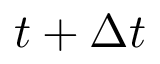Convert formula to latex. <formula><loc_0><loc_0><loc_500><loc_500>t + \Delta t</formula> 